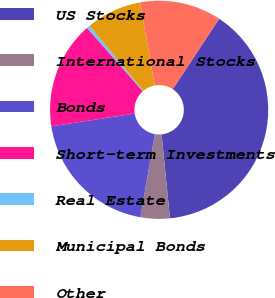<chart> <loc_0><loc_0><loc_500><loc_500><pie_chart><fcel>US Stocks<fcel>International Stocks<fcel>Bonds<fcel>Short-term Investments<fcel>Real Estate<fcel>Municipal Bonds<fcel>Other<nl><fcel>39.15%<fcel>4.34%<fcel>19.82%<fcel>15.95%<fcel>0.47%<fcel>8.21%<fcel>12.08%<nl></chart> 